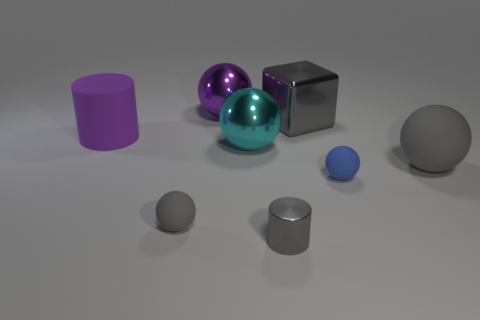Which objects appear to have reflective surfaces? In this image, the teal sphere and the large metallic cube have reflective surfaces that mirror the environment. The smaller silver cylinder and the smaller purple sphere to some extent show reflectiveness as well. 